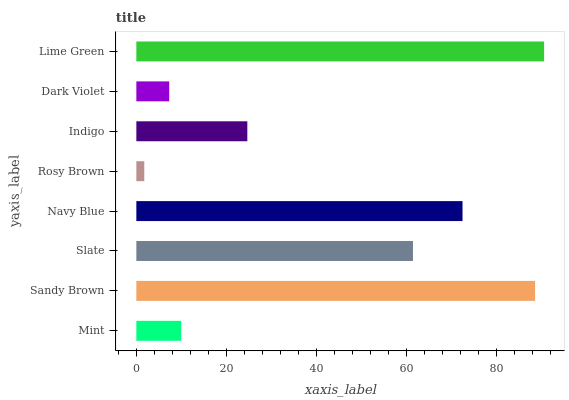Is Rosy Brown the minimum?
Answer yes or no. Yes. Is Lime Green the maximum?
Answer yes or no. Yes. Is Sandy Brown the minimum?
Answer yes or no. No. Is Sandy Brown the maximum?
Answer yes or no. No. Is Sandy Brown greater than Mint?
Answer yes or no. Yes. Is Mint less than Sandy Brown?
Answer yes or no. Yes. Is Mint greater than Sandy Brown?
Answer yes or no. No. Is Sandy Brown less than Mint?
Answer yes or no. No. Is Slate the high median?
Answer yes or no. Yes. Is Indigo the low median?
Answer yes or no. Yes. Is Dark Violet the high median?
Answer yes or no. No. Is Rosy Brown the low median?
Answer yes or no. No. 